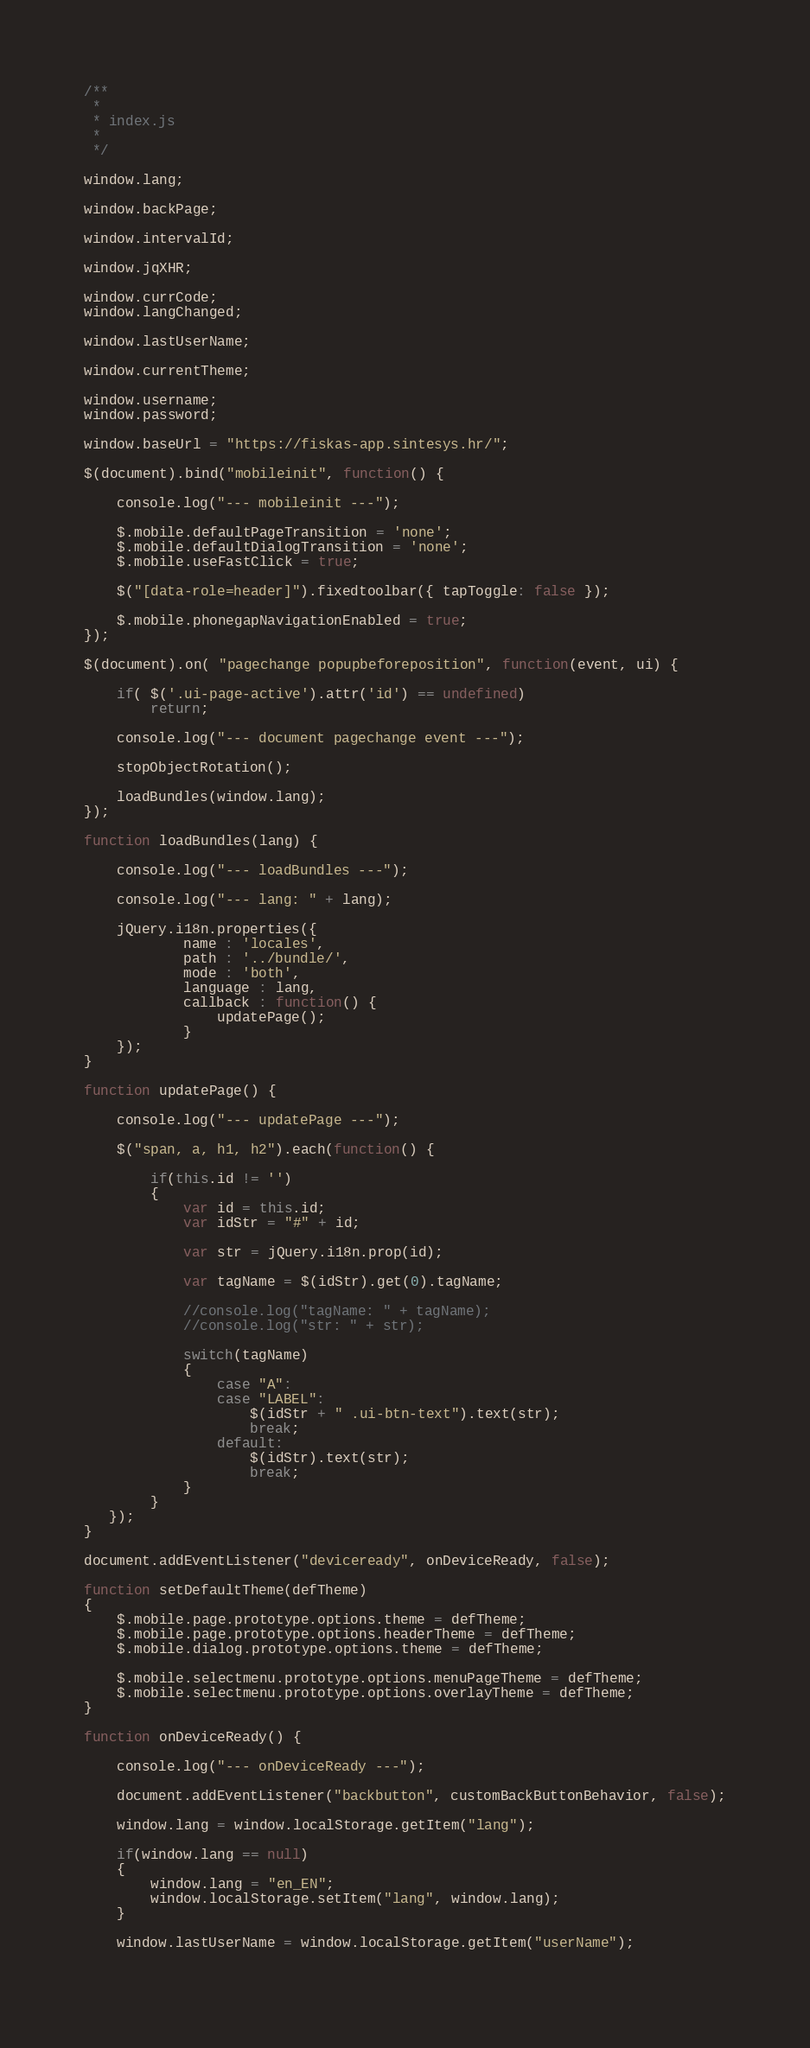Convert code to text. <code><loc_0><loc_0><loc_500><loc_500><_JavaScript_>/**
 * 
 * index.js
 * 
 */

window.lang;

window.backPage;

window.intervalId;

window.jqXHR;

window.currCode;
window.langChanged;

window.lastUserName;

window.currentTheme;

window.username;
window.password;

window.baseUrl = "https://fiskas-app.sintesys.hr/";

$(document).bind("mobileinit", function() {

	console.log("--- mobileinit ---");

	$.mobile.defaultPageTransition = 'none';
	$.mobile.defaultDialogTransition = 'none';
	$.mobile.useFastClick = true;
	
	$("[data-role=header]").fixedtoolbar({ tapToggle: false });
	
	$.mobile.phonegapNavigationEnabled = true;	
});

$(document).on( "pagechange popupbeforeposition", function(event, ui) { 

	if( $('.ui-page-active').attr('id') == undefined)
		return;
	
	console.log("--- document pagechange event ---");
	
	stopObjectRotation();
	
	loadBundles(window.lang);
});

function loadBundles(lang) {
	
	console.log("--- loadBundles ---");
	
	console.log("--- lang: " + lang);

    jQuery.i18n.properties({
            name : 'locales',
            path : '../bundle/',
            mode : 'both',
            language : lang,
            callback : function() {
            	updatePage();
            }
    });
}

function updatePage() {
	
	console.log("--- updatePage ---");

	$("span, a, h1, h2").each(function() { 
   	
		if(this.id != '')
		{
			var id = this.id;
			var idStr = "#" + id;
			
			var str = jQuery.i18n.prop(id);
			
			var tagName = $(idStr).get(0).tagName;
			
			//console.log("tagName: " + tagName);
			//console.log("str: " + str);
			
			switch(tagName)
			{
				case "A":
				case "LABEL":
					$(idStr + " .ui-btn-text").text(str);
					break;
				default:
					$(idStr).text(str);
					break;
			}
		}		
   });
}

document.addEventListener("deviceready", onDeviceReady, false);

function setDefaultTheme(defTheme)
{
    $.mobile.page.prototype.options.theme = defTheme;
	$.mobile.page.prototype.options.headerTheme = defTheme;
	$.mobile.dialog.prototype.options.theme = defTheme;

	$.mobile.selectmenu.prototype.options.menuPageTheme = defTheme;
	$.mobile.selectmenu.prototype.options.overlayTheme = defTheme;
}

function onDeviceReady() {
	
	console.log("--- onDeviceReady ---");
	
    document.addEventListener("backbutton", customBackButtonBehavior, false);
    
    window.lang = window.localStorage.getItem("lang");
        
    if(window.lang == null)
    {
    	window.lang = "en_EN";
    	window.localStorage.setItem("lang", window.lang);
    }
    
    window.lastUserName = window.localStorage.getItem("userName");
     </code> 